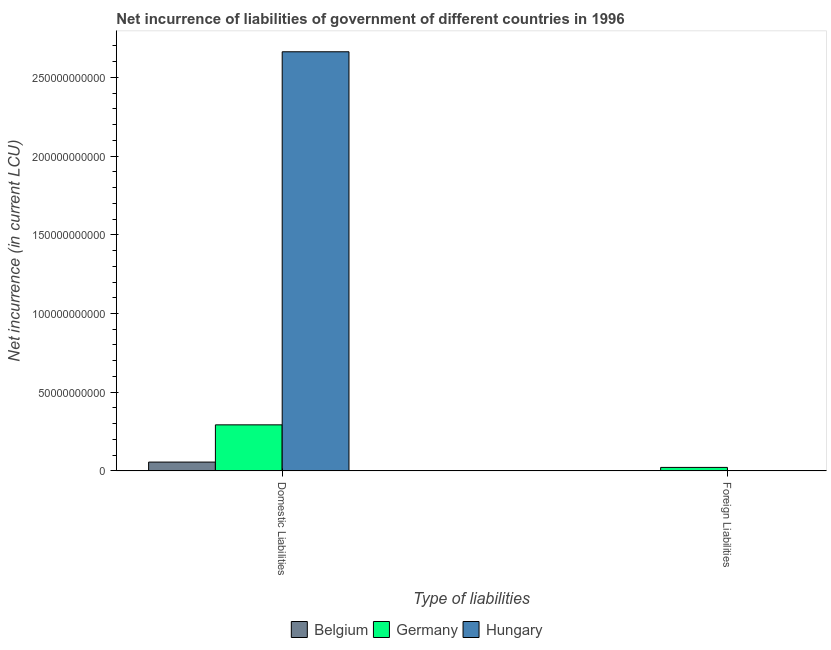Are the number of bars on each tick of the X-axis equal?
Your response must be concise. No. What is the label of the 2nd group of bars from the left?
Offer a terse response. Foreign Liabilities. What is the net incurrence of domestic liabilities in Belgium?
Keep it short and to the point. 5.59e+09. Across all countries, what is the maximum net incurrence of foreign liabilities?
Offer a terse response. 2.20e+09. Across all countries, what is the minimum net incurrence of foreign liabilities?
Provide a succinct answer. 0. In which country was the net incurrence of domestic liabilities maximum?
Keep it short and to the point. Hungary. What is the total net incurrence of domestic liabilities in the graph?
Give a very brief answer. 3.01e+11. What is the difference between the net incurrence of domestic liabilities in Belgium and that in Germany?
Offer a very short reply. -2.37e+1. What is the difference between the net incurrence of domestic liabilities in Hungary and the net incurrence of foreign liabilities in Belgium?
Offer a very short reply. 2.66e+11. What is the average net incurrence of foreign liabilities per country?
Your answer should be compact. 7.35e+08. What is the difference between the net incurrence of foreign liabilities and net incurrence of domestic liabilities in Germany?
Make the answer very short. -2.70e+1. In how many countries, is the net incurrence of domestic liabilities greater than 50000000000 LCU?
Make the answer very short. 1. What is the ratio of the net incurrence of domestic liabilities in Germany to that in Hungary?
Provide a short and direct response. 0.11. How many bars are there?
Make the answer very short. 4. Are all the bars in the graph horizontal?
Your answer should be compact. No. Are the values on the major ticks of Y-axis written in scientific E-notation?
Your answer should be very brief. No. What is the title of the graph?
Give a very brief answer. Net incurrence of liabilities of government of different countries in 1996. Does "Denmark" appear as one of the legend labels in the graph?
Make the answer very short. No. What is the label or title of the X-axis?
Ensure brevity in your answer.  Type of liabilities. What is the label or title of the Y-axis?
Provide a succinct answer. Net incurrence (in current LCU). What is the Net incurrence (in current LCU) of Belgium in Domestic Liabilities?
Offer a very short reply. 5.59e+09. What is the Net incurrence (in current LCU) of Germany in Domestic Liabilities?
Your answer should be compact. 2.92e+1. What is the Net incurrence (in current LCU) of Hungary in Domestic Liabilities?
Your response must be concise. 2.66e+11. What is the Net incurrence (in current LCU) in Germany in Foreign Liabilities?
Make the answer very short. 2.20e+09. Across all Type of liabilities, what is the maximum Net incurrence (in current LCU) of Belgium?
Your answer should be very brief. 5.59e+09. Across all Type of liabilities, what is the maximum Net incurrence (in current LCU) in Germany?
Provide a short and direct response. 2.92e+1. Across all Type of liabilities, what is the maximum Net incurrence (in current LCU) of Hungary?
Your response must be concise. 2.66e+11. Across all Type of liabilities, what is the minimum Net incurrence (in current LCU) of Belgium?
Provide a succinct answer. 0. Across all Type of liabilities, what is the minimum Net incurrence (in current LCU) in Germany?
Your answer should be compact. 2.20e+09. Across all Type of liabilities, what is the minimum Net incurrence (in current LCU) in Hungary?
Provide a succinct answer. 0. What is the total Net incurrence (in current LCU) of Belgium in the graph?
Provide a succinct answer. 5.59e+09. What is the total Net incurrence (in current LCU) of Germany in the graph?
Provide a short and direct response. 3.15e+1. What is the total Net incurrence (in current LCU) of Hungary in the graph?
Provide a short and direct response. 2.66e+11. What is the difference between the Net incurrence (in current LCU) of Germany in Domestic Liabilities and that in Foreign Liabilities?
Keep it short and to the point. 2.70e+1. What is the difference between the Net incurrence (in current LCU) in Belgium in Domestic Liabilities and the Net incurrence (in current LCU) in Germany in Foreign Liabilities?
Ensure brevity in your answer.  3.39e+09. What is the average Net incurrence (in current LCU) of Belgium per Type of liabilities?
Ensure brevity in your answer.  2.80e+09. What is the average Net incurrence (in current LCU) in Germany per Type of liabilities?
Offer a terse response. 1.57e+1. What is the average Net incurrence (in current LCU) of Hungary per Type of liabilities?
Offer a very short reply. 1.33e+11. What is the difference between the Net incurrence (in current LCU) of Belgium and Net incurrence (in current LCU) of Germany in Domestic Liabilities?
Your response must be concise. -2.37e+1. What is the difference between the Net incurrence (in current LCU) in Belgium and Net incurrence (in current LCU) in Hungary in Domestic Liabilities?
Ensure brevity in your answer.  -2.61e+11. What is the difference between the Net incurrence (in current LCU) in Germany and Net incurrence (in current LCU) in Hungary in Domestic Liabilities?
Make the answer very short. -2.37e+11. What is the ratio of the Net incurrence (in current LCU) of Germany in Domestic Liabilities to that in Foreign Liabilities?
Offer a terse response. 13.27. What is the difference between the highest and the second highest Net incurrence (in current LCU) of Germany?
Offer a terse response. 2.70e+1. What is the difference between the highest and the lowest Net incurrence (in current LCU) in Belgium?
Ensure brevity in your answer.  5.59e+09. What is the difference between the highest and the lowest Net incurrence (in current LCU) of Germany?
Your response must be concise. 2.70e+1. What is the difference between the highest and the lowest Net incurrence (in current LCU) of Hungary?
Make the answer very short. 2.66e+11. 